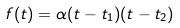<formula> <loc_0><loc_0><loc_500><loc_500>f ( t ) = \alpha ( t - t _ { 1 } ) ( t - t _ { 2 } )</formula> 